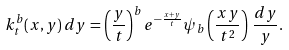Convert formula to latex. <formula><loc_0><loc_0><loc_500><loc_500>k _ { t } ^ { b } ( x , y ) \, d y = \left ( \frac { y } { t } \right ) ^ { b } e ^ { - \frac { x + y } { t } } \psi _ { b } \left ( \frac { x y } { t ^ { 2 } } \right ) \, \frac { d y } { y } .</formula> 